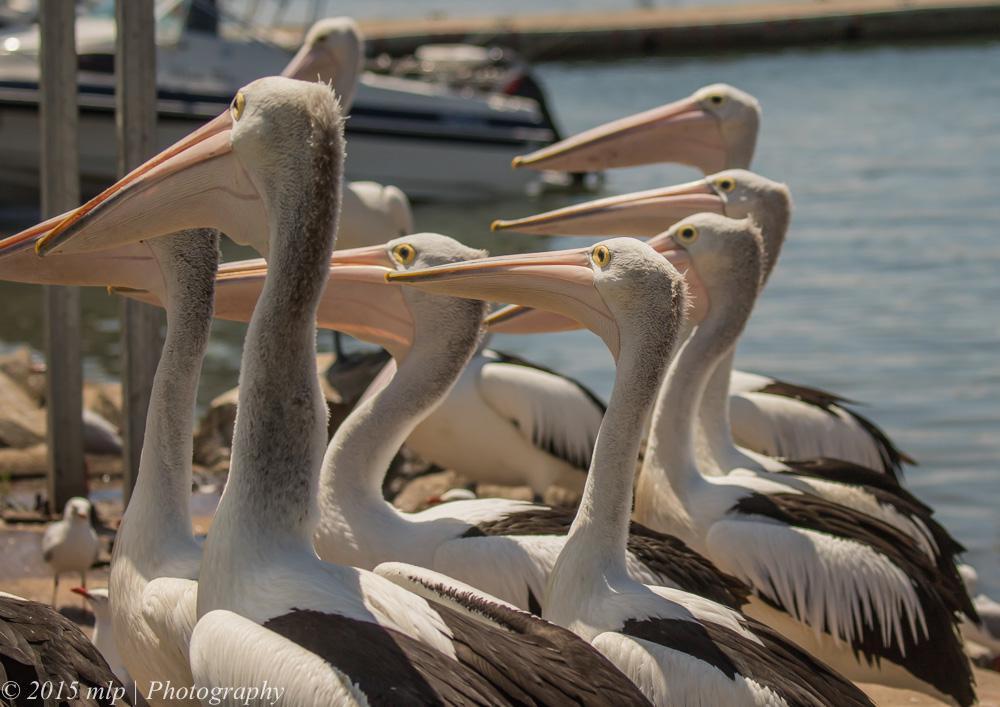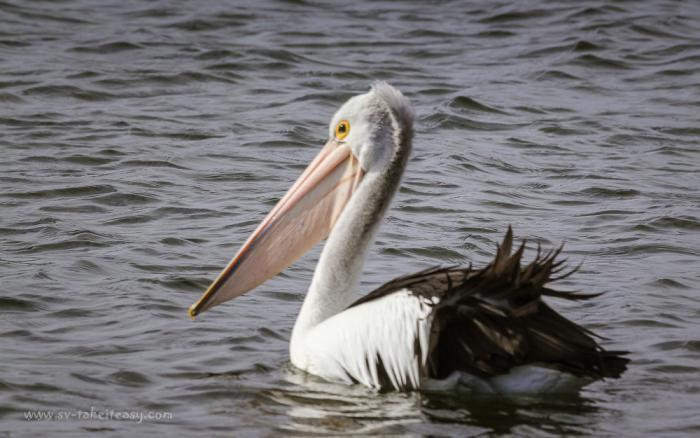The first image is the image on the left, the second image is the image on the right. Evaluate the accuracy of this statement regarding the images: "Left image contains only one pelican, which is on water.". Is it true? Answer yes or no. No. The first image is the image on the left, the second image is the image on the right. Given the left and right images, does the statement "The left image shows one pelican floating on the water" hold true? Answer yes or no. No. 